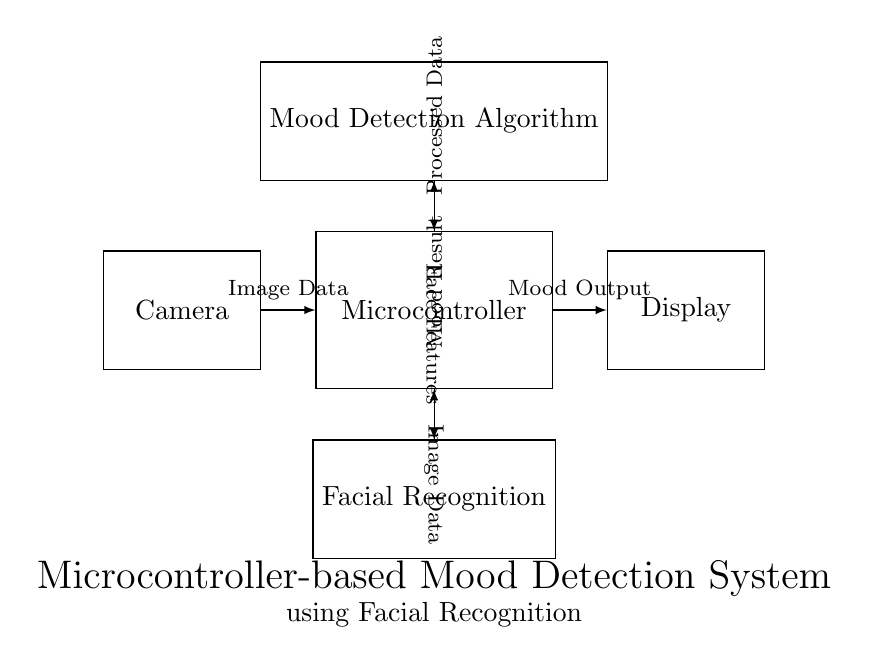What is the primary component in this circuit? The primary component is the Microcontroller, which acts as the central processing unit for the system.
Answer: Microcontroller What kind of data does the camera send to the microcontroller? The camera sends Image Data to the microcontroller, which is necessary for processing the mood detection.
Answer: Image Data What is the function of the mood detection algorithm? The mood detection algorithm processes the data received from the microcontroller and determines the mood based on the facial recognition inputs.
Answer: Mood detection How many components are directly connected to the microcontroller? There are three components directly connected to the microcontroller: the Camera, the Display, and the Facial Recognition unit.
Answer: Three What type of output does the microcontroller send to the display? The microcontroller sends the Mood Output to the display, which indicates the processed mood result for the user.
Answer: Mood Output What type of features does the facial recognition unit send back to the microcontroller? The facial recognition unit sends Face Features back to the microcontroller to facilitate the processing of mood analysis.
Answer: Face Features What data does the microcontroller process from the mood detection algorithm? The microcontroller processes the Processed Data received from the mood detection algorithm, which helps in producing the final mood result.
Answer: Processed Data 